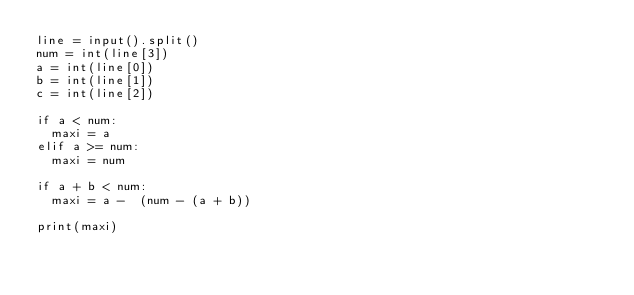<code> <loc_0><loc_0><loc_500><loc_500><_Python_>line = input().split()
num = int(line[3])
a = int(line[0])
b = int(line[1])
c = int(line[2])

if a < num:
  maxi = a
elif a >= num:
  maxi = num

if a + b < num:
  maxi = a -  (num - (a + b))
  
print(maxi)</code> 